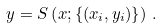Convert formula to latex. <formula><loc_0><loc_0><loc_500><loc_500>y = S \left ( x ; \left \{ ( x _ { i } , y _ { i } ) \right \} \right ) \, .</formula> 